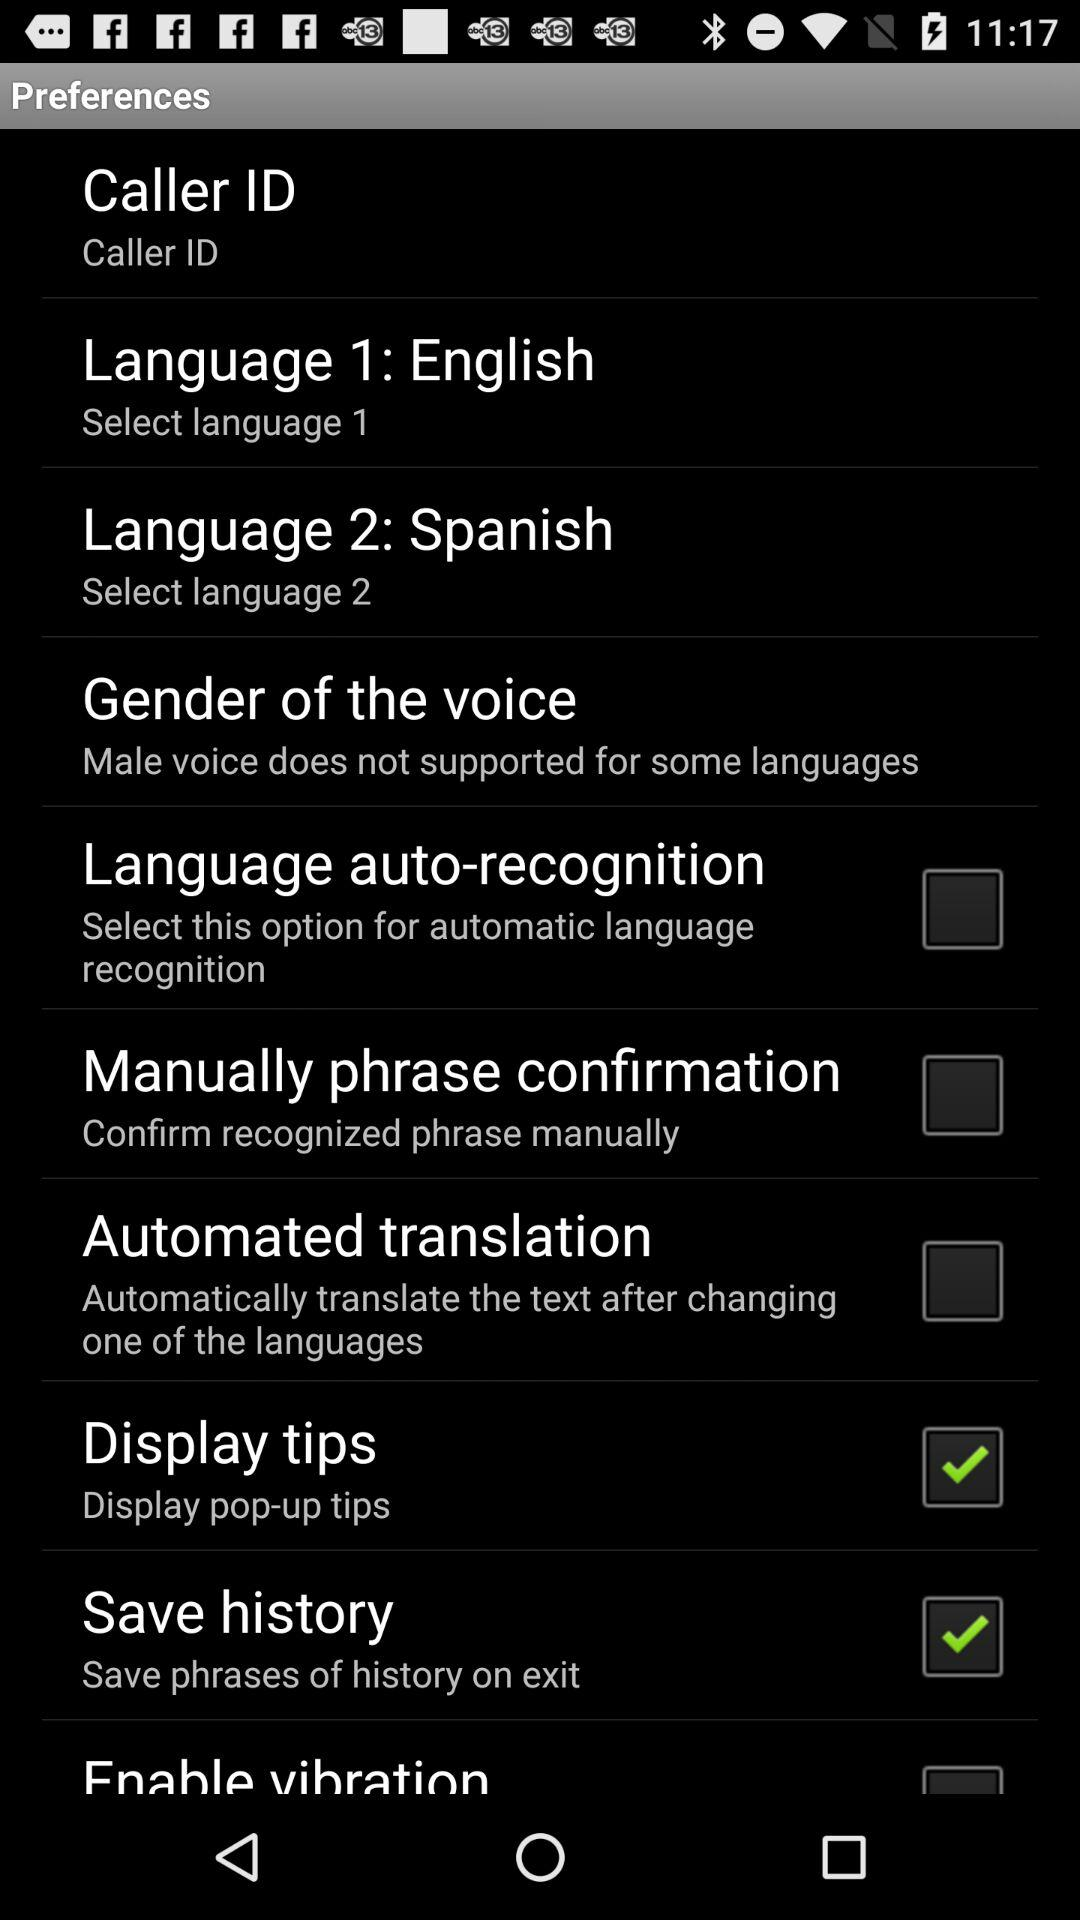What is the status of "Save history"? The status of "Save history" is "on". 